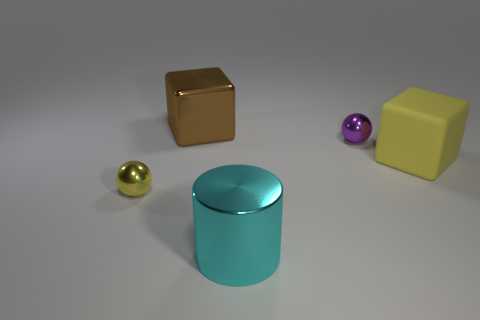Add 4 large yellow rubber objects. How many objects exist? 9 Subtract all spheres. How many objects are left? 3 Subtract 0 blue blocks. How many objects are left? 5 Subtract all big brown cylinders. Subtract all tiny objects. How many objects are left? 3 Add 3 large cubes. How many large cubes are left? 5 Add 3 yellow metal cubes. How many yellow metal cubes exist? 3 